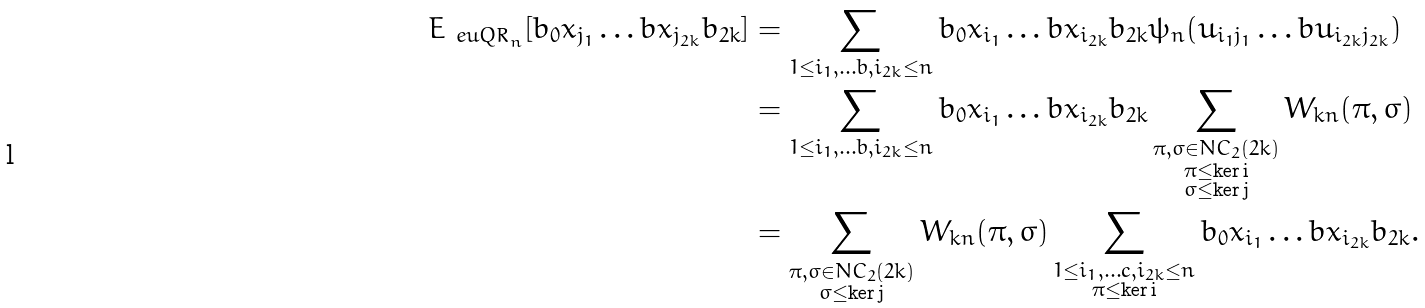Convert formula to latex. <formula><loc_0><loc_0><loc_500><loc_500>E _ { \ e u { Q R } _ { n } } [ b _ { 0 } x _ { j _ { 1 } } \dots b x _ { j _ { 2 k } } b _ { 2 k } ] & = \sum _ { 1 \leq i _ { 1 } , \dots b , i _ { 2 k } \leq n } b _ { 0 } x _ { i _ { 1 } } \dots b x _ { i _ { 2 k } } b _ { 2 k } \psi _ { n } ( u _ { i _ { 1 } j _ { 1 } } \dots b u _ { i _ { 2 k } j _ { 2 k } } ) \\ & = \sum _ { 1 \leq i _ { 1 } , \dots b , i _ { 2 k } \leq n } b _ { 0 } x _ { i _ { 1 } } \dots b x _ { i _ { 2 k } } b _ { 2 k } \sum _ { \substack { \pi , \sigma \in N C _ { 2 } ( 2 k ) \\ \pi \leq \ker \mathbf i \\ \sigma \leq \ker \mathbf j } } W _ { k n } ( \pi , \sigma ) \\ & = \sum _ { \substack { \pi , \sigma \in N C _ { 2 } ( 2 k ) \\ \sigma \leq \ker \mathbf j } } W _ { k n } ( \pi , \sigma ) \sum _ { \substack { 1 \leq i _ { 1 } , \dots c , i _ { 2 k } \leq n \\ \pi \leq \ker \mathbf i } } b _ { 0 } x _ { i _ { 1 } } \dots b x _ { i _ { 2 k } } b _ { 2 k } .</formula> 